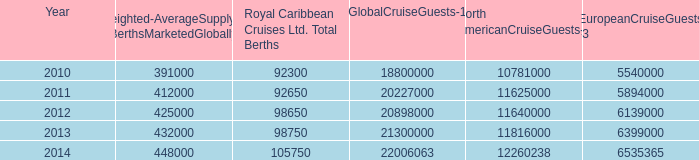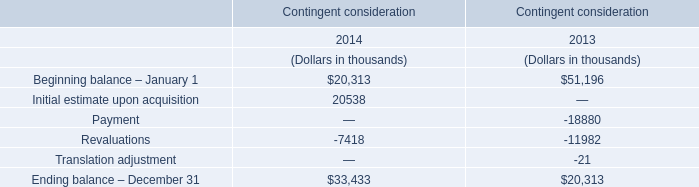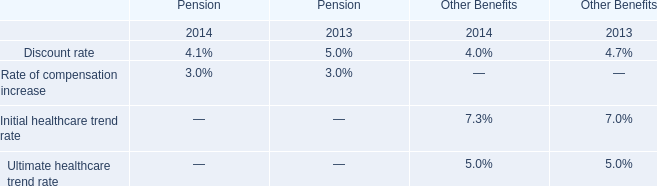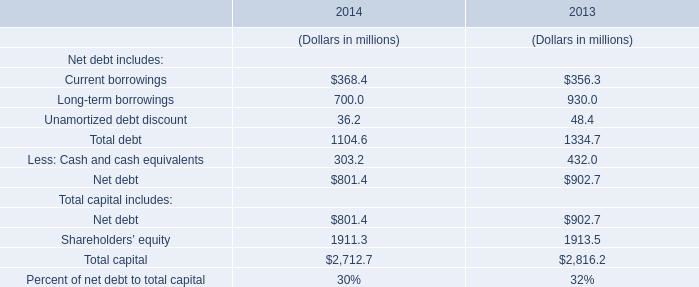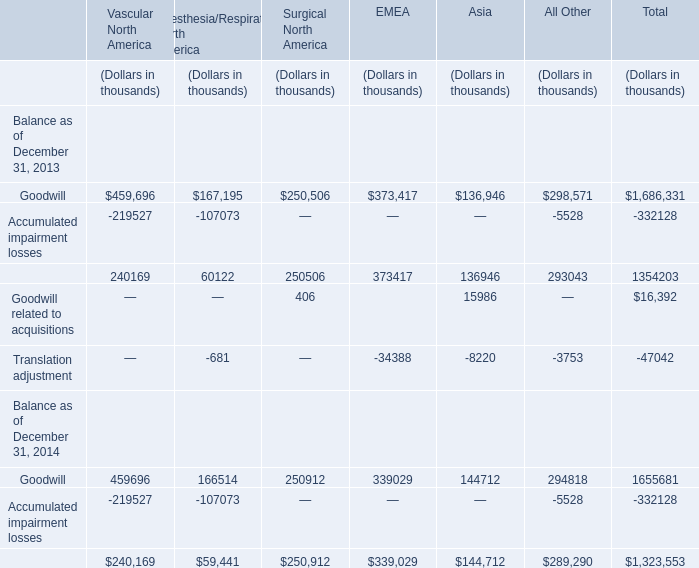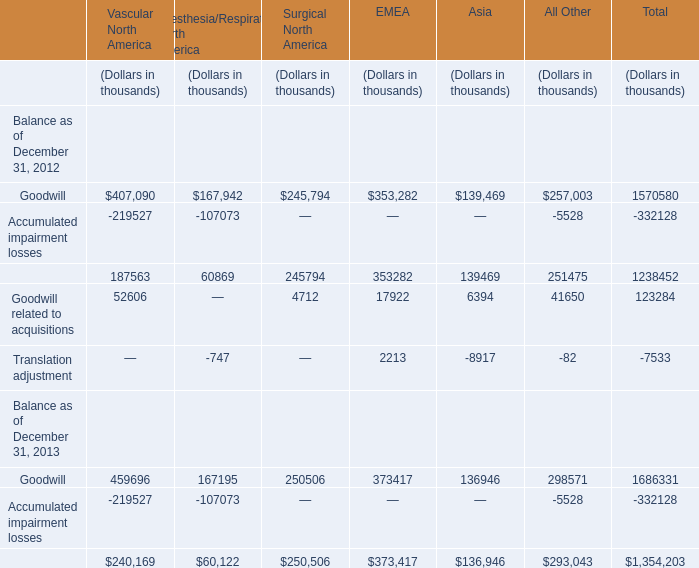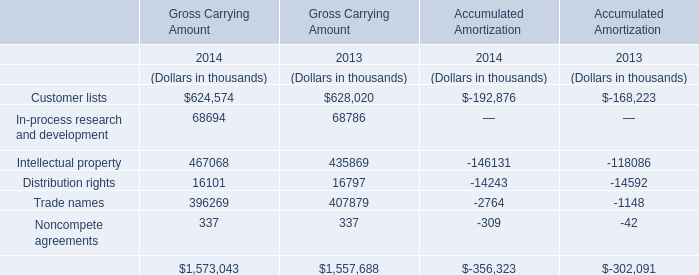If Distribution rights for Gross Carrying Amount develops with the same increasing rate in 2014, what will it reach in 2015? (in thousand) 
Computations: (16101 * (1 + ((16101 - 16797) / 16797)))
Answer: 15433.83944. 